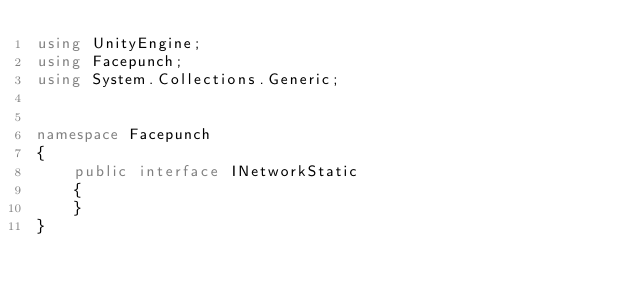Convert code to text. <code><loc_0><loc_0><loc_500><loc_500><_C#_>using UnityEngine;
using Facepunch;
using System.Collections.Generic;


namespace Facepunch
{
	public interface INetworkStatic
	{
	}
}
</code> 